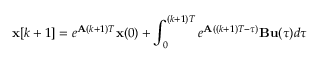Convert formula to latex. <formula><loc_0><loc_0><loc_500><loc_500>x [ k + 1 ] = e ^ { A ( k + 1 ) T } x ( 0 ) + \int _ { 0 } ^ { ( k + 1 ) T } e ^ { A ( ( k + 1 ) T - \tau ) } B u ( \tau ) d \tau</formula> 